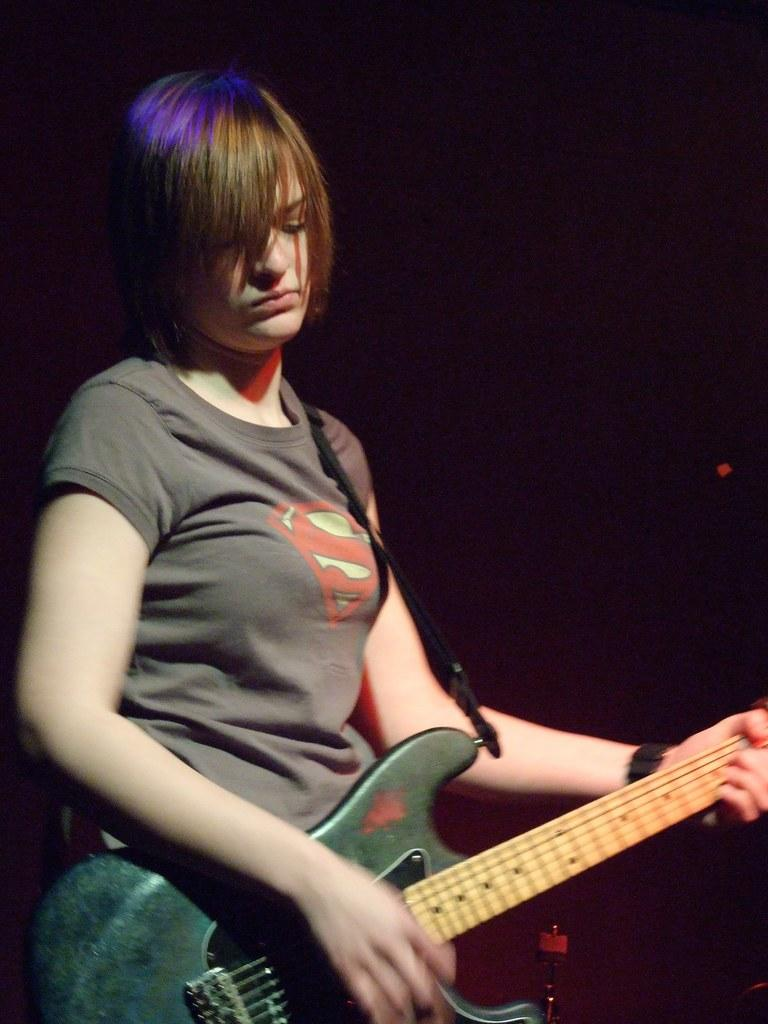What is the main subject of the image? The main subject of the image is a woman. What is the woman doing in the image? The woman is standing and playing a guitar. What type of paste is the woman using to play the guitar in the image? There is no paste present in the image, and the woman is not using any paste to play the guitar. 